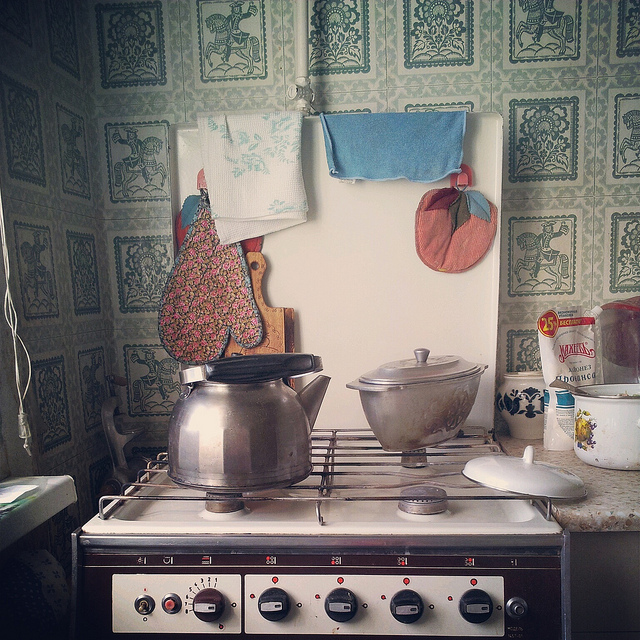Identify and read out the text in this image. 25 